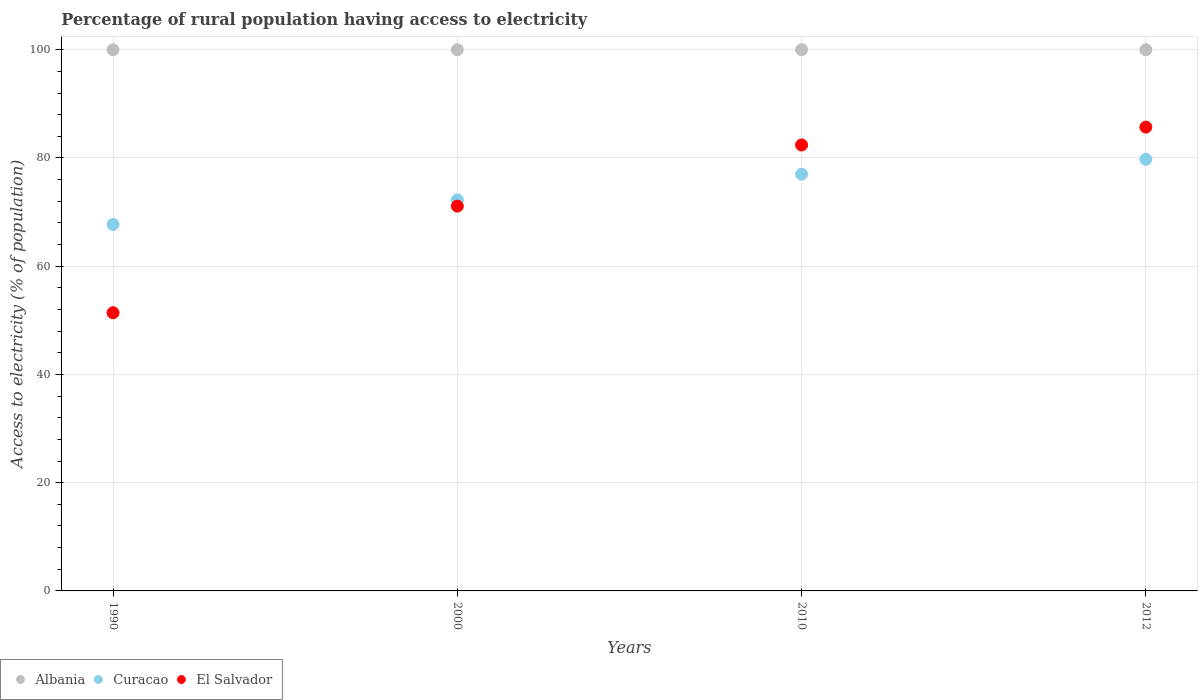How many different coloured dotlines are there?
Give a very brief answer. 3. Is the number of dotlines equal to the number of legend labels?
Your response must be concise. Yes. What is the percentage of rural population having access to electricity in Albania in 2010?
Offer a terse response. 100. Across all years, what is the maximum percentage of rural population having access to electricity in Albania?
Make the answer very short. 100. Across all years, what is the minimum percentage of rural population having access to electricity in El Salvador?
Offer a terse response. 51.4. In which year was the percentage of rural population having access to electricity in El Salvador maximum?
Provide a succinct answer. 2012. What is the total percentage of rural population having access to electricity in Curacao in the graph?
Keep it short and to the point. 296.73. What is the difference between the percentage of rural population having access to electricity in Curacao in 1990 and the percentage of rural population having access to electricity in Albania in 2010?
Your answer should be compact. -32.29. What is the average percentage of rural population having access to electricity in Curacao per year?
Your answer should be very brief. 74.18. In the year 1990, what is the difference between the percentage of rural population having access to electricity in Albania and percentage of rural population having access to electricity in El Salvador?
Your answer should be very brief. 48.6. Is the difference between the percentage of rural population having access to electricity in Albania in 2000 and 2010 greater than the difference between the percentage of rural population having access to electricity in El Salvador in 2000 and 2010?
Provide a succinct answer. Yes. What is the difference between the highest and the second highest percentage of rural population having access to electricity in Curacao?
Provide a short and direct response. 2.75. What is the difference between the highest and the lowest percentage of rural population having access to electricity in Curacao?
Your answer should be compact. 12.04. Is it the case that in every year, the sum of the percentage of rural population having access to electricity in El Salvador and percentage of rural population having access to electricity in Albania  is greater than the percentage of rural population having access to electricity in Curacao?
Offer a terse response. Yes. Is the percentage of rural population having access to electricity in El Salvador strictly less than the percentage of rural population having access to electricity in Curacao over the years?
Keep it short and to the point. No. How many dotlines are there?
Your response must be concise. 3. Does the graph contain any zero values?
Offer a very short reply. No. Does the graph contain grids?
Ensure brevity in your answer.  Yes. Where does the legend appear in the graph?
Ensure brevity in your answer.  Bottom left. How many legend labels are there?
Give a very brief answer. 3. How are the legend labels stacked?
Your response must be concise. Horizontal. What is the title of the graph?
Your response must be concise. Percentage of rural population having access to electricity. Does "Turks and Caicos Islands" appear as one of the legend labels in the graph?
Offer a terse response. No. What is the label or title of the X-axis?
Your answer should be compact. Years. What is the label or title of the Y-axis?
Offer a very short reply. Access to electricity (% of population). What is the Access to electricity (% of population) in Curacao in 1990?
Your response must be concise. 67.71. What is the Access to electricity (% of population) in El Salvador in 1990?
Your answer should be very brief. 51.4. What is the Access to electricity (% of population) of Albania in 2000?
Offer a very short reply. 100. What is the Access to electricity (% of population) in Curacao in 2000?
Your response must be concise. 72.27. What is the Access to electricity (% of population) in El Salvador in 2000?
Provide a succinct answer. 71.1. What is the Access to electricity (% of population) of Curacao in 2010?
Ensure brevity in your answer.  77. What is the Access to electricity (% of population) in El Salvador in 2010?
Keep it short and to the point. 82.4. What is the Access to electricity (% of population) of Curacao in 2012?
Give a very brief answer. 79.75. What is the Access to electricity (% of population) of El Salvador in 2012?
Provide a short and direct response. 85.7. Across all years, what is the maximum Access to electricity (% of population) in Albania?
Offer a very short reply. 100. Across all years, what is the maximum Access to electricity (% of population) in Curacao?
Ensure brevity in your answer.  79.75. Across all years, what is the maximum Access to electricity (% of population) in El Salvador?
Keep it short and to the point. 85.7. Across all years, what is the minimum Access to electricity (% of population) in Curacao?
Provide a succinct answer. 67.71. Across all years, what is the minimum Access to electricity (% of population) in El Salvador?
Provide a short and direct response. 51.4. What is the total Access to electricity (% of population) of Curacao in the graph?
Ensure brevity in your answer.  296.73. What is the total Access to electricity (% of population) in El Salvador in the graph?
Provide a succinct answer. 290.6. What is the difference between the Access to electricity (% of population) in Albania in 1990 and that in 2000?
Keep it short and to the point. 0. What is the difference between the Access to electricity (% of population) of Curacao in 1990 and that in 2000?
Keep it short and to the point. -4.55. What is the difference between the Access to electricity (% of population) of El Salvador in 1990 and that in 2000?
Offer a very short reply. -19.7. What is the difference between the Access to electricity (% of population) in Curacao in 1990 and that in 2010?
Your answer should be compact. -9.29. What is the difference between the Access to electricity (% of population) of El Salvador in 1990 and that in 2010?
Your response must be concise. -31. What is the difference between the Access to electricity (% of population) in Curacao in 1990 and that in 2012?
Give a very brief answer. -12.04. What is the difference between the Access to electricity (% of population) in El Salvador in 1990 and that in 2012?
Keep it short and to the point. -34.3. What is the difference between the Access to electricity (% of population) of Curacao in 2000 and that in 2010?
Ensure brevity in your answer.  -4.74. What is the difference between the Access to electricity (% of population) of El Salvador in 2000 and that in 2010?
Ensure brevity in your answer.  -11.3. What is the difference between the Access to electricity (% of population) of Curacao in 2000 and that in 2012?
Offer a terse response. -7.49. What is the difference between the Access to electricity (% of population) in El Salvador in 2000 and that in 2012?
Your answer should be compact. -14.6. What is the difference between the Access to electricity (% of population) of Albania in 2010 and that in 2012?
Ensure brevity in your answer.  0. What is the difference between the Access to electricity (% of population) in Curacao in 2010 and that in 2012?
Provide a short and direct response. -2.75. What is the difference between the Access to electricity (% of population) in El Salvador in 2010 and that in 2012?
Offer a terse response. -3.3. What is the difference between the Access to electricity (% of population) in Albania in 1990 and the Access to electricity (% of population) in Curacao in 2000?
Offer a very short reply. 27.73. What is the difference between the Access to electricity (% of population) in Albania in 1990 and the Access to electricity (% of population) in El Salvador in 2000?
Provide a short and direct response. 28.9. What is the difference between the Access to electricity (% of population) of Curacao in 1990 and the Access to electricity (% of population) of El Salvador in 2000?
Provide a short and direct response. -3.39. What is the difference between the Access to electricity (% of population) of Albania in 1990 and the Access to electricity (% of population) of Curacao in 2010?
Ensure brevity in your answer.  23. What is the difference between the Access to electricity (% of population) of Curacao in 1990 and the Access to electricity (% of population) of El Salvador in 2010?
Provide a succinct answer. -14.69. What is the difference between the Access to electricity (% of population) in Albania in 1990 and the Access to electricity (% of population) in Curacao in 2012?
Offer a terse response. 20.25. What is the difference between the Access to electricity (% of population) in Curacao in 1990 and the Access to electricity (% of population) in El Salvador in 2012?
Offer a very short reply. -17.99. What is the difference between the Access to electricity (% of population) in Albania in 2000 and the Access to electricity (% of population) in Curacao in 2010?
Keep it short and to the point. 23. What is the difference between the Access to electricity (% of population) of Curacao in 2000 and the Access to electricity (% of population) of El Salvador in 2010?
Offer a terse response. -10.13. What is the difference between the Access to electricity (% of population) in Albania in 2000 and the Access to electricity (% of population) in Curacao in 2012?
Your response must be concise. 20.25. What is the difference between the Access to electricity (% of population) of Albania in 2000 and the Access to electricity (% of population) of El Salvador in 2012?
Offer a terse response. 14.3. What is the difference between the Access to electricity (% of population) of Curacao in 2000 and the Access to electricity (% of population) of El Salvador in 2012?
Give a very brief answer. -13.44. What is the difference between the Access to electricity (% of population) in Albania in 2010 and the Access to electricity (% of population) in Curacao in 2012?
Make the answer very short. 20.25. What is the average Access to electricity (% of population) in Curacao per year?
Offer a very short reply. 74.18. What is the average Access to electricity (% of population) in El Salvador per year?
Your answer should be very brief. 72.65. In the year 1990, what is the difference between the Access to electricity (% of population) of Albania and Access to electricity (% of population) of Curacao?
Keep it short and to the point. 32.29. In the year 1990, what is the difference between the Access to electricity (% of population) in Albania and Access to electricity (% of population) in El Salvador?
Keep it short and to the point. 48.6. In the year 1990, what is the difference between the Access to electricity (% of population) of Curacao and Access to electricity (% of population) of El Salvador?
Your answer should be very brief. 16.31. In the year 2000, what is the difference between the Access to electricity (% of population) in Albania and Access to electricity (% of population) in Curacao?
Your answer should be compact. 27.73. In the year 2000, what is the difference between the Access to electricity (% of population) of Albania and Access to electricity (% of population) of El Salvador?
Your answer should be compact. 28.9. In the year 2000, what is the difference between the Access to electricity (% of population) in Curacao and Access to electricity (% of population) in El Salvador?
Keep it short and to the point. 1.17. In the year 2010, what is the difference between the Access to electricity (% of population) in Albania and Access to electricity (% of population) in El Salvador?
Your response must be concise. 17.6. In the year 2010, what is the difference between the Access to electricity (% of population) in Curacao and Access to electricity (% of population) in El Salvador?
Offer a very short reply. -5.4. In the year 2012, what is the difference between the Access to electricity (% of population) of Albania and Access to electricity (% of population) of Curacao?
Your answer should be very brief. 20.25. In the year 2012, what is the difference between the Access to electricity (% of population) of Curacao and Access to electricity (% of population) of El Salvador?
Your answer should be compact. -5.95. What is the ratio of the Access to electricity (% of population) of Curacao in 1990 to that in 2000?
Your answer should be compact. 0.94. What is the ratio of the Access to electricity (% of population) of El Salvador in 1990 to that in 2000?
Offer a terse response. 0.72. What is the ratio of the Access to electricity (% of population) in Curacao in 1990 to that in 2010?
Your answer should be very brief. 0.88. What is the ratio of the Access to electricity (% of population) in El Salvador in 1990 to that in 2010?
Ensure brevity in your answer.  0.62. What is the ratio of the Access to electricity (% of population) in Albania in 1990 to that in 2012?
Keep it short and to the point. 1. What is the ratio of the Access to electricity (% of population) of Curacao in 1990 to that in 2012?
Make the answer very short. 0.85. What is the ratio of the Access to electricity (% of population) of El Salvador in 1990 to that in 2012?
Offer a terse response. 0.6. What is the ratio of the Access to electricity (% of population) of Albania in 2000 to that in 2010?
Your answer should be very brief. 1. What is the ratio of the Access to electricity (% of population) in Curacao in 2000 to that in 2010?
Your answer should be compact. 0.94. What is the ratio of the Access to electricity (% of population) in El Salvador in 2000 to that in 2010?
Make the answer very short. 0.86. What is the ratio of the Access to electricity (% of population) in Albania in 2000 to that in 2012?
Give a very brief answer. 1. What is the ratio of the Access to electricity (% of population) of Curacao in 2000 to that in 2012?
Give a very brief answer. 0.91. What is the ratio of the Access to electricity (% of population) of El Salvador in 2000 to that in 2012?
Give a very brief answer. 0.83. What is the ratio of the Access to electricity (% of population) of Curacao in 2010 to that in 2012?
Offer a very short reply. 0.97. What is the ratio of the Access to electricity (% of population) of El Salvador in 2010 to that in 2012?
Offer a very short reply. 0.96. What is the difference between the highest and the second highest Access to electricity (% of population) of Curacao?
Your answer should be very brief. 2.75. What is the difference between the highest and the second highest Access to electricity (% of population) in El Salvador?
Give a very brief answer. 3.3. What is the difference between the highest and the lowest Access to electricity (% of population) in Curacao?
Make the answer very short. 12.04. What is the difference between the highest and the lowest Access to electricity (% of population) of El Salvador?
Give a very brief answer. 34.3. 